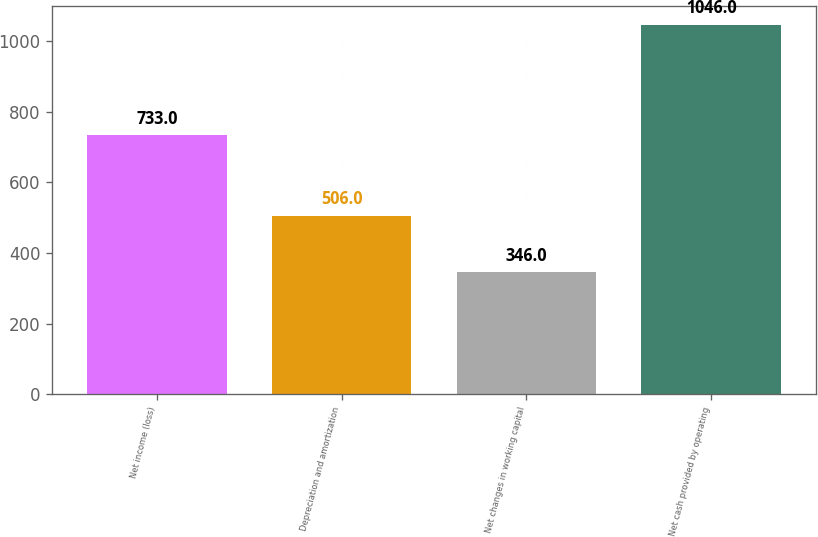Convert chart. <chart><loc_0><loc_0><loc_500><loc_500><bar_chart><fcel>Net income (loss)<fcel>Depreciation and amortization<fcel>Net changes in working capital<fcel>Net cash provided by operating<nl><fcel>733<fcel>506<fcel>346<fcel>1046<nl></chart> 